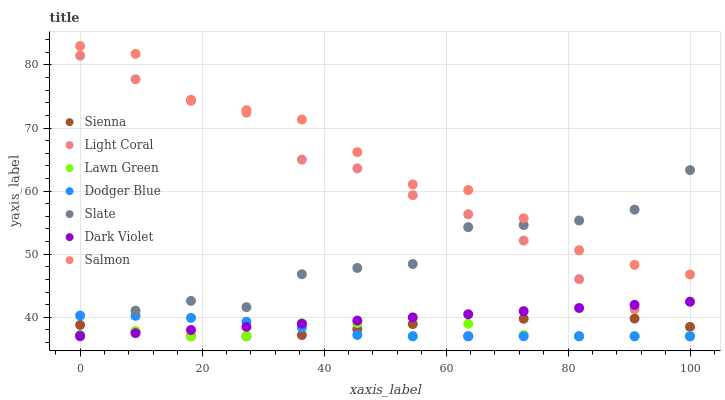Does Lawn Green have the minimum area under the curve?
Answer yes or no. Yes. Does Salmon have the maximum area under the curve?
Answer yes or no. Yes. Does Slate have the minimum area under the curve?
Answer yes or no. No. Does Slate have the maximum area under the curve?
Answer yes or no. No. Is Dark Violet the smoothest?
Answer yes or no. Yes. Is Slate the roughest?
Answer yes or no. Yes. Is Lawn Green the smoothest?
Answer yes or no. No. Is Lawn Green the roughest?
Answer yes or no. No. Does Light Coral have the lowest value?
Answer yes or no. Yes. Does Slate have the lowest value?
Answer yes or no. No. Does Salmon have the highest value?
Answer yes or no. Yes. Does Slate have the highest value?
Answer yes or no. No. Is Lawn Green less than Salmon?
Answer yes or no. Yes. Is Salmon greater than Dodger Blue?
Answer yes or no. Yes. Does Lawn Green intersect Dodger Blue?
Answer yes or no. Yes. Is Lawn Green less than Dodger Blue?
Answer yes or no. No. Is Lawn Green greater than Dodger Blue?
Answer yes or no. No. Does Lawn Green intersect Salmon?
Answer yes or no. No. 